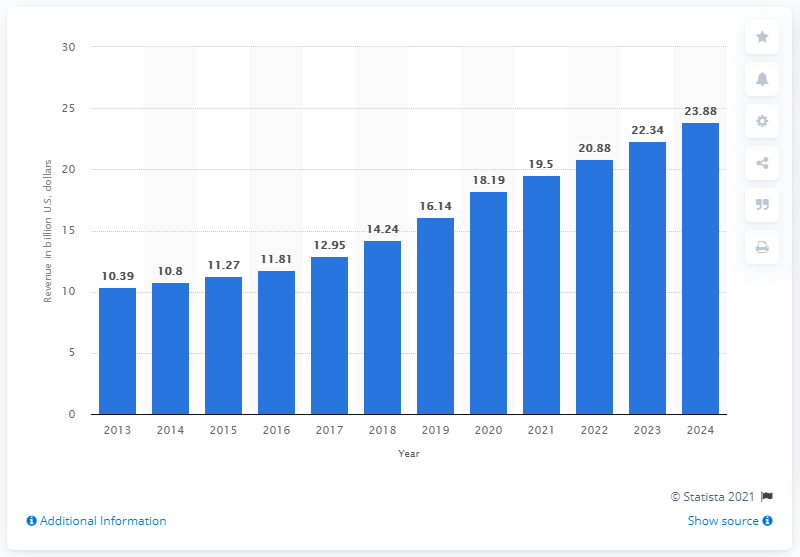Mention a couple of crucial points in this snapshot. The global revenue of Este Lauder for the year 2018 was 14.24 billion US dollars. 